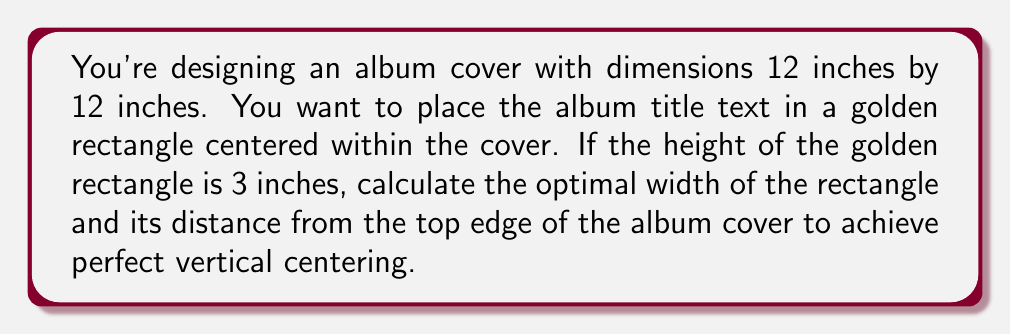Teach me how to tackle this problem. Let's approach this step-by-step:

1) First, recall that in a golden rectangle, the ratio of the longer side to the shorter side is equal to the golden ratio, φ (phi). The golden ratio is approximately 1.618.

2) We're given that the height of the rectangle is 3 inches. Let's call the width x. The golden ratio formula is:

   $$\frac{x}{3} = \frac{3}{x} + 1 = φ ≈ 1.618$$

3) Solving for x:
   $$x = 3 * 1.618 = 4.854 \text{ inches}$$

4) Now that we have the dimensions of the golden rectangle, let's center it vertically on the album cover.

5) The album cover is 12 inches tall. The golden rectangle is 3 inches tall. The remaining space is:
   $$12 - 3 = 9 \text{ inches}$$

6) To center the rectangle, we divide this remaining space equally above and below:
   $$\frac{9}{2} = 4.5 \text{ inches}$$

7) Therefore, the distance from the top edge of the album cover to the top of the golden rectangle is 4.5 inches.

[asy]
size(200);
draw((0,0)--(12,0)--(12,12)--(0,12)--cycle);
fill((3.573,4.5)--(8.427,4.5)--(8.427,7.5)--(3.573,7.5)--cycle, gray(0.9));
label("12\"", (12,6), E);
label("12\"", (6,12), N);
label("3\"", (8.5,6), E);
label("4.854\"", (6,4.3), S);
label("4.5\"", (0,2.25), W);
[/asy]
Answer: Width: 4.854 inches, Distance from top: 4.5 inches 